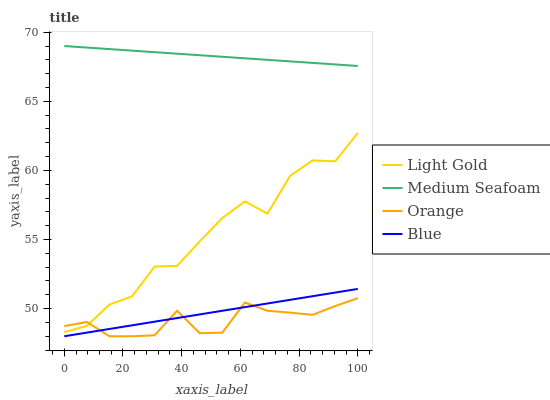Does Orange have the minimum area under the curve?
Answer yes or no. Yes. Does Medium Seafoam have the maximum area under the curve?
Answer yes or no. Yes. Does Blue have the minimum area under the curve?
Answer yes or no. No. Does Blue have the maximum area under the curve?
Answer yes or no. No. Is Blue the smoothest?
Answer yes or no. Yes. Is Light Gold the roughest?
Answer yes or no. Yes. Is Light Gold the smoothest?
Answer yes or no. No. Is Blue the roughest?
Answer yes or no. No. Does Orange have the lowest value?
Answer yes or no. Yes. Does Light Gold have the lowest value?
Answer yes or no. No. Does Medium Seafoam have the highest value?
Answer yes or no. Yes. Does Blue have the highest value?
Answer yes or no. No. Is Blue less than Medium Seafoam?
Answer yes or no. Yes. Is Medium Seafoam greater than Blue?
Answer yes or no. Yes. Does Light Gold intersect Orange?
Answer yes or no. Yes. Is Light Gold less than Orange?
Answer yes or no. No. Is Light Gold greater than Orange?
Answer yes or no. No. Does Blue intersect Medium Seafoam?
Answer yes or no. No. 